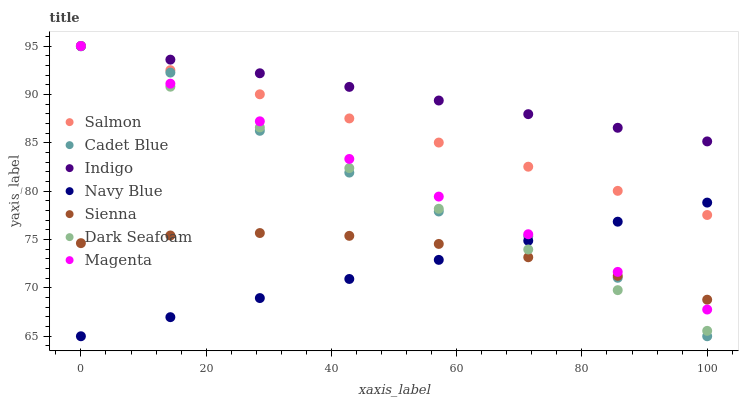Does Navy Blue have the minimum area under the curve?
Answer yes or no. Yes. Does Indigo have the maximum area under the curve?
Answer yes or no. Yes. Does Indigo have the minimum area under the curve?
Answer yes or no. No. Does Navy Blue have the maximum area under the curve?
Answer yes or no. No. Is Indigo the smoothest?
Answer yes or no. Yes. Is Cadet Blue the roughest?
Answer yes or no. Yes. Is Navy Blue the smoothest?
Answer yes or no. No. Is Navy Blue the roughest?
Answer yes or no. No. Does Cadet Blue have the lowest value?
Answer yes or no. Yes. Does Indigo have the lowest value?
Answer yes or no. No. Does Magenta have the highest value?
Answer yes or no. Yes. Does Navy Blue have the highest value?
Answer yes or no. No. Is Navy Blue less than Indigo?
Answer yes or no. Yes. Is Indigo greater than Cadet Blue?
Answer yes or no. Yes. Does Salmon intersect Indigo?
Answer yes or no. Yes. Is Salmon less than Indigo?
Answer yes or no. No. Is Salmon greater than Indigo?
Answer yes or no. No. Does Navy Blue intersect Indigo?
Answer yes or no. No. 